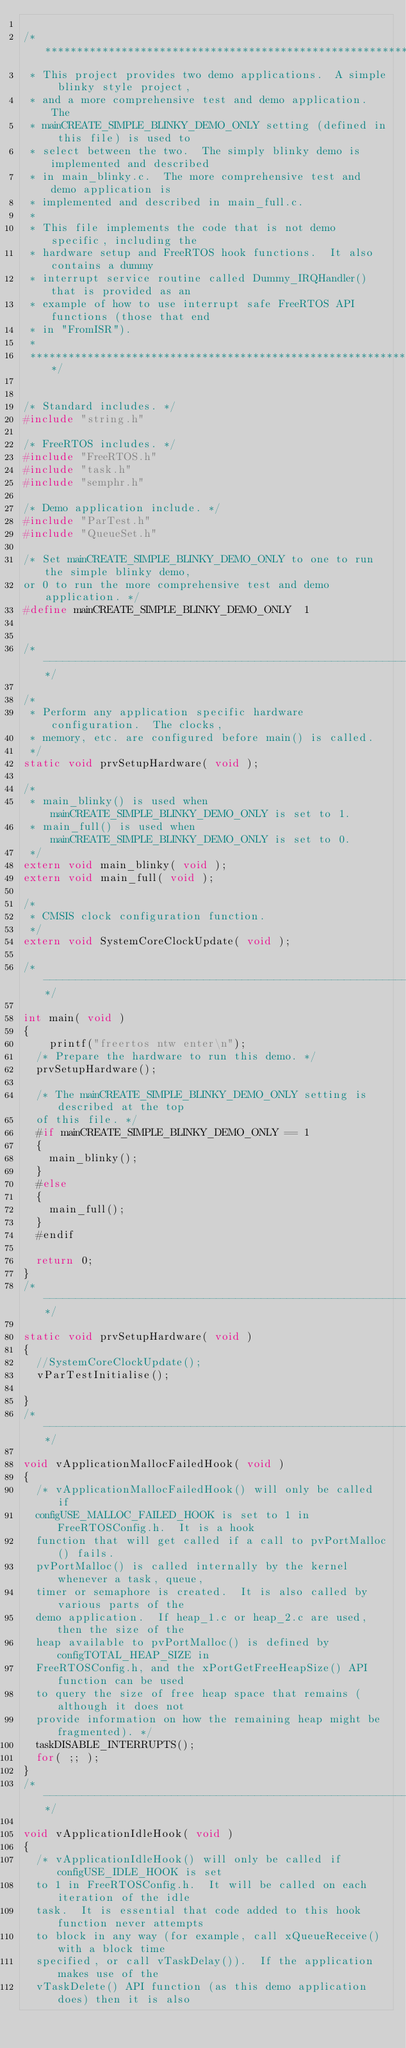<code> <loc_0><loc_0><loc_500><loc_500><_C_>
/******************************************************************************
 * This project provides two demo applications.  A simple blinky style project,
 * and a more comprehensive test and demo application.  The
 * mainCREATE_SIMPLE_BLINKY_DEMO_ONLY setting (defined in this file) is used to
 * select between the two.  The simply blinky demo is implemented and described
 * in main_blinky.c.  The more comprehensive test and demo application is
 * implemented and described in main_full.c.
 *
 * This file implements the code that is not demo specific, including the
 * hardware setup and FreeRTOS hook functions.  It also contains a dummy
 * interrupt service routine called Dummy_IRQHandler() that is provided as an
 * example of how to use interrupt safe FreeRTOS API functions (those that end
 * in "FromISR").
 *
 *****************************************************************************/


/* Standard includes. */
#include "string.h"

/* FreeRTOS includes. */
#include "FreeRTOS.h"
#include "task.h"
#include "semphr.h"

/* Demo application include. */
#include "ParTest.h"
#include "QueueSet.h"

/* Set mainCREATE_SIMPLE_BLINKY_DEMO_ONLY to one to run the simple blinky demo,
or 0 to run the more comprehensive test and demo application. */
#define mainCREATE_SIMPLE_BLINKY_DEMO_ONLY	1


/*-----------------------------------------------------------*/

/*
 * Perform any application specific hardware configuration.  The clocks,
 * memory, etc. are configured before main() is called.
 */
static void prvSetupHardware( void );

/*
 * main_blinky() is used when mainCREATE_SIMPLE_BLINKY_DEMO_ONLY is set to 1.
 * main_full() is used when mainCREATE_SIMPLE_BLINKY_DEMO_ONLY is set to 0.
 */
extern void main_blinky( void );
extern void main_full( void );

/*
 * CMSIS clock configuration function.
 */
extern void SystemCoreClockUpdate( void );

/*-----------------------------------------------------------*/

int main( void )
{
    printf("freertos ntw enter\n");
	/* Prepare the hardware to run this demo. */
	prvSetupHardware();

	/* The mainCREATE_SIMPLE_BLINKY_DEMO_ONLY setting is described at the top
	of this file. */
	#if mainCREATE_SIMPLE_BLINKY_DEMO_ONLY == 1
	{
		main_blinky();
	}
	#else
	{
		main_full();
	}
	#endif

	return 0;
}
/*-----------------------------------------------------------*/

static void prvSetupHardware( void )
{
	//SystemCoreClockUpdate();
	vParTestInitialise();
    
}
/*-----------------------------------------------------------*/

void vApplicationMallocFailedHook( void )
{
	/* vApplicationMallocFailedHook() will only be called if
	configUSE_MALLOC_FAILED_HOOK is set to 1 in FreeRTOSConfig.h.  It is a hook
	function that will get called if a call to pvPortMalloc() fails.
	pvPortMalloc() is called internally by the kernel whenever a task, queue,
	timer or semaphore is created.  It is also called by various parts of the
	demo application.  If heap_1.c or heap_2.c are used, then the size of the
	heap available to pvPortMalloc() is defined by configTOTAL_HEAP_SIZE in
	FreeRTOSConfig.h, and the xPortGetFreeHeapSize() API function can be used
	to query the size of free heap space that remains (although it does not
	provide information on how the remaining heap might be fragmented). */
	taskDISABLE_INTERRUPTS();
	for( ;; );
}
/*-----------------------------------------------------------*/

void vApplicationIdleHook( void )
{
	/* vApplicationIdleHook() will only be called if configUSE_IDLE_HOOK is set
	to 1 in FreeRTOSConfig.h.  It will be called on each iteration of the idle
	task.  It is essential that code added to this hook function never attempts
	to block in any way (for example, call xQueueReceive() with a block time
	specified, or call vTaskDelay()).  If the application makes use of the
	vTaskDelete() API function (as this demo application does) then it is also</code> 